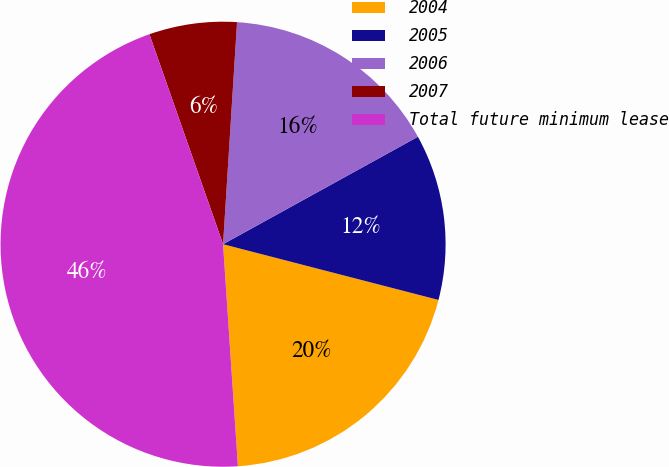Convert chart to OTSL. <chart><loc_0><loc_0><loc_500><loc_500><pie_chart><fcel>2004<fcel>2005<fcel>2006<fcel>2007<fcel>Total future minimum lease<nl><fcel>19.91%<fcel>12.05%<fcel>15.98%<fcel>6.37%<fcel>45.7%<nl></chart> 